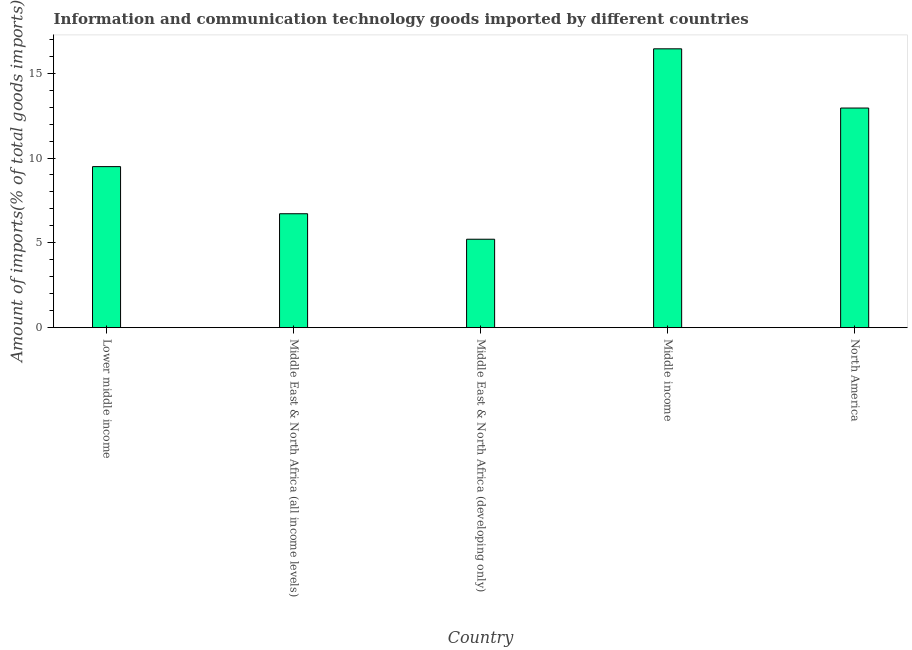Does the graph contain grids?
Offer a very short reply. No. What is the title of the graph?
Offer a terse response. Information and communication technology goods imported by different countries. What is the label or title of the Y-axis?
Offer a very short reply. Amount of imports(% of total goods imports). What is the amount of ict goods imports in Middle income?
Provide a succinct answer. 16.44. Across all countries, what is the maximum amount of ict goods imports?
Give a very brief answer. 16.44. Across all countries, what is the minimum amount of ict goods imports?
Provide a succinct answer. 5.21. In which country was the amount of ict goods imports maximum?
Offer a terse response. Middle income. In which country was the amount of ict goods imports minimum?
Give a very brief answer. Middle East & North Africa (developing only). What is the sum of the amount of ict goods imports?
Ensure brevity in your answer.  50.81. What is the difference between the amount of ict goods imports in Middle income and North America?
Provide a short and direct response. 3.49. What is the average amount of ict goods imports per country?
Make the answer very short. 10.16. What is the median amount of ict goods imports?
Give a very brief answer. 9.49. In how many countries, is the amount of ict goods imports greater than 1 %?
Ensure brevity in your answer.  5. What is the ratio of the amount of ict goods imports in Middle income to that in North America?
Keep it short and to the point. 1.27. Is the difference between the amount of ict goods imports in Lower middle income and North America greater than the difference between any two countries?
Give a very brief answer. No. What is the difference between the highest and the second highest amount of ict goods imports?
Your answer should be compact. 3.49. Is the sum of the amount of ict goods imports in Lower middle income and North America greater than the maximum amount of ict goods imports across all countries?
Keep it short and to the point. Yes. What is the difference between the highest and the lowest amount of ict goods imports?
Make the answer very short. 11.22. What is the Amount of imports(% of total goods imports) in Lower middle income?
Make the answer very short. 9.49. What is the Amount of imports(% of total goods imports) in Middle East & North Africa (all income levels)?
Provide a short and direct response. 6.72. What is the Amount of imports(% of total goods imports) in Middle East & North Africa (developing only)?
Provide a succinct answer. 5.21. What is the Amount of imports(% of total goods imports) of Middle income?
Your response must be concise. 16.44. What is the Amount of imports(% of total goods imports) in North America?
Provide a succinct answer. 12.95. What is the difference between the Amount of imports(% of total goods imports) in Lower middle income and Middle East & North Africa (all income levels)?
Provide a short and direct response. 2.78. What is the difference between the Amount of imports(% of total goods imports) in Lower middle income and Middle East & North Africa (developing only)?
Offer a terse response. 4.28. What is the difference between the Amount of imports(% of total goods imports) in Lower middle income and Middle income?
Your answer should be compact. -6.94. What is the difference between the Amount of imports(% of total goods imports) in Lower middle income and North America?
Your answer should be very brief. -3.45. What is the difference between the Amount of imports(% of total goods imports) in Middle East & North Africa (all income levels) and Middle East & North Africa (developing only)?
Provide a short and direct response. 1.5. What is the difference between the Amount of imports(% of total goods imports) in Middle East & North Africa (all income levels) and Middle income?
Your response must be concise. -9.72. What is the difference between the Amount of imports(% of total goods imports) in Middle East & North Africa (all income levels) and North America?
Your response must be concise. -6.23. What is the difference between the Amount of imports(% of total goods imports) in Middle East & North Africa (developing only) and Middle income?
Give a very brief answer. -11.22. What is the difference between the Amount of imports(% of total goods imports) in Middle East & North Africa (developing only) and North America?
Make the answer very short. -7.73. What is the difference between the Amount of imports(% of total goods imports) in Middle income and North America?
Offer a terse response. 3.49. What is the ratio of the Amount of imports(% of total goods imports) in Lower middle income to that in Middle East & North Africa (all income levels)?
Your answer should be very brief. 1.41. What is the ratio of the Amount of imports(% of total goods imports) in Lower middle income to that in Middle East & North Africa (developing only)?
Give a very brief answer. 1.82. What is the ratio of the Amount of imports(% of total goods imports) in Lower middle income to that in Middle income?
Keep it short and to the point. 0.58. What is the ratio of the Amount of imports(% of total goods imports) in Lower middle income to that in North America?
Your response must be concise. 0.73. What is the ratio of the Amount of imports(% of total goods imports) in Middle East & North Africa (all income levels) to that in Middle East & North Africa (developing only)?
Provide a succinct answer. 1.29. What is the ratio of the Amount of imports(% of total goods imports) in Middle East & North Africa (all income levels) to that in Middle income?
Ensure brevity in your answer.  0.41. What is the ratio of the Amount of imports(% of total goods imports) in Middle East & North Africa (all income levels) to that in North America?
Your response must be concise. 0.52. What is the ratio of the Amount of imports(% of total goods imports) in Middle East & North Africa (developing only) to that in Middle income?
Ensure brevity in your answer.  0.32. What is the ratio of the Amount of imports(% of total goods imports) in Middle East & North Africa (developing only) to that in North America?
Your answer should be compact. 0.4. What is the ratio of the Amount of imports(% of total goods imports) in Middle income to that in North America?
Provide a succinct answer. 1.27. 